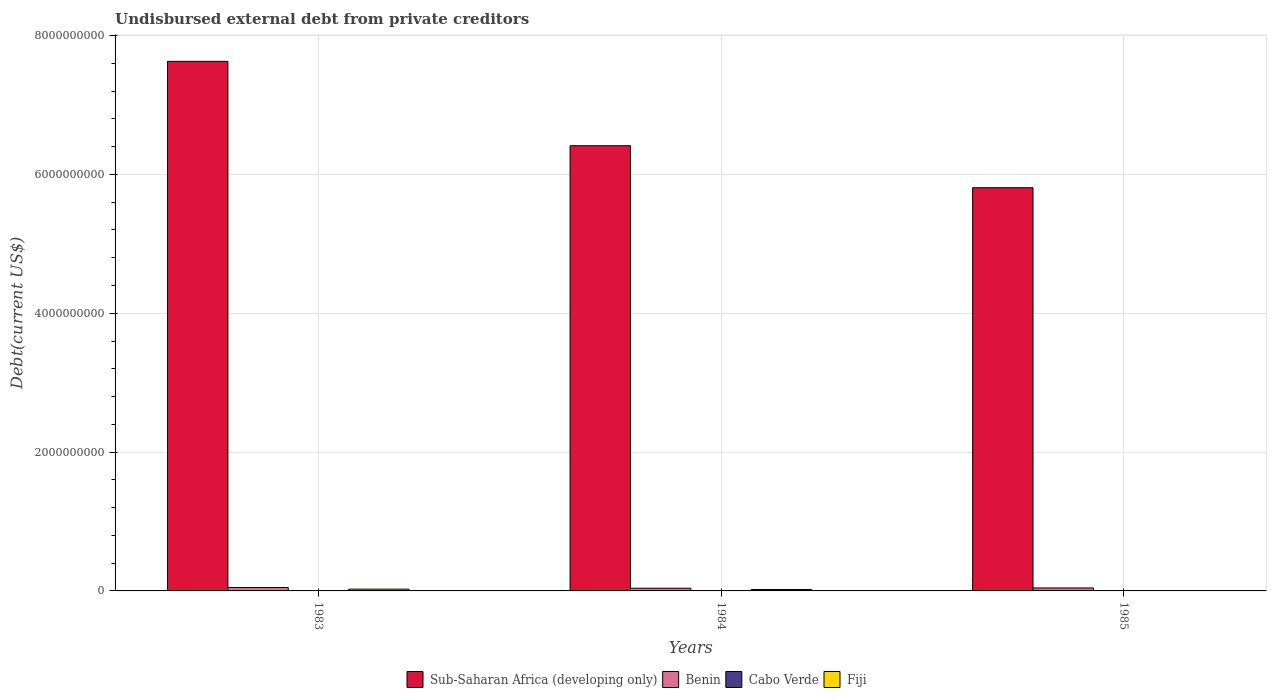How many different coloured bars are there?
Keep it short and to the point. 4. How many groups of bars are there?
Provide a short and direct response. 3. Are the number of bars per tick equal to the number of legend labels?
Offer a terse response. Yes. How many bars are there on the 1st tick from the right?
Make the answer very short. 4. What is the label of the 3rd group of bars from the left?
Provide a succinct answer. 1985. What is the total debt in Sub-Saharan Africa (developing only) in 1984?
Keep it short and to the point. 6.41e+09. Across all years, what is the maximum total debt in Benin?
Offer a very short reply. 4.94e+07. Across all years, what is the minimum total debt in Benin?
Your answer should be very brief. 3.91e+07. In which year was the total debt in Sub-Saharan Africa (developing only) minimum?
Ensure brevity in your answer.  1985. What is the total total debt in Cabo Verde in the graph?
Your response must be concise. 5.15e+06. What is the difference between the total debt in Sub-Saharan Africa (developing only) in 1983 and that in 1985?
Keep it short and to the point. 1.82e+09. What is the difference between the total debt in Benin in 1983 and the total debt in Cabo Verde in 1985?
Your answer should be compact. 4.88e+07. What is the average total debt in Fiji per year?
Offer a very short reply. 1.62e+07. In the year 1985, what is the difference between the total debt in Fiji and total debt in Benin?
Give a very brief answer. -4.09e+07. What is the ratio of the total debt in Cabo Verde in 1984 to that in 1985?
Provide a succinct answer. 2.64. Is the difference between the total debt in Fiji in 1984 and 1985 greater than the difference between the total debt in Benin in 1984 and 1985?
Your answer should be very brief. Yes. What is the difference between the highest and the second highest total debt in Fiji?
Your response must be concise. 4.91e+06. What is the difference between the highest and the lowest total debt in Sub-Saharan Africa (developing only)?
Provide a succinct answer. 1.82e+09. Is the sum of the total debt in Benin in 1983 and 1985 greater than the maximum total debt in Sub-Saharan Africa (developing only) across all years?
Provide a succinct answer. No. Is it the case that in every year, the sum of the total debt in Benin and total debt in Cabo Verde is greater than the sum of total debt in Sub-Saharan Africa (developing only) and total debt in Fiji?
Keep it short and to the point. No. What does the 3rd bar from the left in 1983 represents?
Your response must be concise. Cabo Verde. What does the 3rd bar from the right in 1984 represents?
Provide a succinct answer. Benin. What is the difference between two consecutive major ticks on the Y-axis?
Give a very brief answer. 2.00e+09. Are the values on the major ticks of Y-axis written in scientific E-notation?
Your answer should be very brief. No. Does the graph contain any zero values?
Your answer should be compact. No. Does the graph contain grids?
Provide a short and direct response. Yes. How many legend labels are there?
Ensure brevity in your answer.  4. What is the title of the graph?
Provide a succinct answer. Undisbursed external debt from private creditors. What is the label or title of the Y-axis?
Provide a succinct answer. Debt(current US$). What is the Debt(current US$) in Sub-Saharan Africa (developing only) in 1983?
Offer a terse response. 7.63e+09. What is the Debt(current US$) in Benin in 1983?
Provide a succinct answer. 4.94e+07. What is the Debt(current US$) of Cabo Verde in 1983?
Make the answer very short. 3.00e+06. What is the Debt(current US$) in Fiji in 1983?
Your response must be concise. 2.58e+07. What is the Debt(current US$) of Sub-Saharan Africa (developing only) in 1984?
Provide a short and direct response. 6.41e+09. What is the Debt(current US$) of Benin in 1984?
Your answer should be very brief. 3.91e+07. What is the Debt(current US$) in Cabo Verde in 1984?
Your answer should be compact. 1.56e+06. What is the Debt(current US$) of Fiji in 1984?
Your answer should be very brief. 2.09e+07. What is the Debt(current US$) in Sub-Saharan Africa (developing only) in 1985?
Offer a terse response. 5.81e+09. What is the Debt(current US$) of Benin in 1985?
Offer a very short reply. 4.27e+07. What is the Debt(current US$) in Cabo Verde in 1985?
Offer a terse response. 5.91e+05. What is the Debt(current US$) of Fiji in 1985?
Ensure brevity in your answer.  1.78e+06. Across all years, what is the maximum Debt(current US$) in Sub-Saharan Africa (developing only)?
Give a very brief answer. 7.63e+09. Across all years, what is the maximum Debt(current US$) in Benin?
Your answer should be very brief. 4.94e+07. Across all years, what is the maximum Debt(current US$) of Cabo Verde?
Ensure brevity in your answer.  3.00e+06. Across all years, what is the maximum Debt(current US$) in Fiji?
Your answer should be compact. 2.58e+07. Across all years, what is the minimum Debt(current US$) in Sub-Saharan Africa (developing only)?
Your answer should be very brief. 5.81e+09. Across all years, what is the minimum Debt(current US$) of Benin?
Provide a succinct answer. 3.91e+07. Across all years, what is the minimum Debt(current US$) of Cabo Verde?
Offer a very short reply. 5.91e+05. Across all years, what is the minimum Debt(current US$) in Fiji?
Offer a very short reply. 1.78e+06. What is the total Debt(current US$) in Sub-Saharan Africa (developing only) in the graph?
Your answer should be compact. 1.99e+1. What is the total Debt(current US$) in Benin in the graph?
Offer a terse response. 1.31e+08. What is the total Debt(current US$) in Cabo Verde in the graph?
Your answer should be compact. 5.15e+06. What is the total Debt(current US$) in Fiji in the graph?
Give a very brief answer. 4.85e+07. What is the difference between the Debt(current US$) in Sub-Saharan Africa (developing only) in 1983 and that in 1984?
Keep it short and to the point. 1.22e+09. What is the difference between the Debt(current US$) of Benin in 1983 and that in 1984?
Make the answer very short. 1.04e+07. What is the difference between the Debt(current US$) of Cabo Verde in 1983 and that in 1984?
Provide a short and direct response. 1.44e+06. What is the difference between the Debt(current US$) in Fiji in 1983 and that in 1984?
Ensure brevity in your answer.  4.91e+06. What is the difference between the Debt(current US$) of Sub-Saharan Africa (developing only) in 1983 and that in 1985?
Offer a very short reply. 1.82e+09. What is the difference between the Debt(current US$) in Benin in 1983 and that in 1985?
Keep it short and to the point. 6.72e+06. What is the difference between the Debt(current US$) of Cabo Verde in 1983 and that in 1985?
Give a very brief answer. 2.41e+06. What is the difference between the Debt(current US$) in Fiji in 1983 and that in 1985?
Give a very brief answer. 2.40e+07. What is the difference between the Debt(current US$) of Sub-Saharan Africa (developing only) in 1984 and that in 1985?
Your answer should be very brief. 6.05e+08. What is the difference between the Debt(current US$) of Benin in 1984 and that in 1985?
Ensure brevity in your answer.  -3.65e+06. What is the difference between the Debt(current US$) of Cabo Verde in 1984 and that in 1985?
Offer a terse response. 9.72e+05. What is the difference between the Debt(current US$) of Fiji in 1984 and that in 1985?
Your answer should be compact. 1.91e+07. What is the difference between the Debt(current US$) in Sub-Saharan Africa (developing only) in 1983 and the Debt(current US$) in Benin in 1984?
Your answer should be very brief. 7.59e+09. What is the difference between the Debt(current US$) in Sub-Saharan Africa (developing only) in 1983 and the Debt(current US$) in Cabo Verde in 1984?
Your answer should be very brief. 7.63e+09. What is the difference between the Debt(current US$) of Sub-Saharan Africa (developing only) in 1983 and the Debt(current US$) of Fiji in 1984?
Provide a short and direct response. 7.61e+09. What is the difference between the Debt(current US$) of Benin in 1983 and the Debt(current US$) of Cabo Verde in 1984?
Your response must be concise. 4.79e+07. What is the difference between the Debt(current US$) in Benin in 1983 and the Debt(current US$) in Fiji in 1984?
Ensure brevity in your answer.  2.85e+07. What is the difference between the Debt(current US$) in Cabo Verde in 1983 and the Debt(current US$) in Fiji in 1984?
Your response must be concise. -1.79e+07. What is the difference between the Debt(current US$) in Sub-Saharan Africa (developing only) in 1983 and the Debt(current US$) in Benin in 1985?
Offer a very short reply. 7.59e+09. What is the difference between the Debt(current US$) of Sub-Saharan Africa (developing only) in 1983 and the Debt(current US$) of Cabo Verde in 1985?
Keep it short and to the point. 7.63e+09. What is the difference between the Debt(current US$) in Sub-Saharan Africa (developing only) in 1983 and the Debt(current US$) in Fiji in 1985?
Your answer should be compact. 7.63e+09. What is the difference between the Debt(current US$) of Benin in 1983 and the Debt(current US$) of Cabo Verde in 1985?
Provide a succinct answer. 4.88e+07. What is the difference between the Debt(current US$) in Benin in 1983 and the Debt(current US$) in Fiji in 1985?
Your answer should be compact. 4.76e+07. What is the difference between the Debt(current US$) of Cabo Verde in 1983 and the Debt(current US$) of Fiji in 1985?
Keep it short and to the point. 1.22e+06. What is the difference between the Debt(current US$) in Sub-Saharan Africa (developing only) in 1984 and the Debt(current US$) in Benin in 1985?
Your response must be concise. 6.37e+09. What is the difference between the Debt(current US$) in Sub-Saharan Africa (developing only) in 1984 and the Debt(current US$) in Cabo Verde in 1985?
Provide a short and direct response. 6.41e+09. What is the difference between the Debt(current US$) in Sub-Saharan Africa (developing only) in 1984 and the Debt(current US$) in Fiji in 1985?
Your response must be concise. 6.41e+09. What is the difference between the Debt(current US$) in Benin in 1984 and the Debt(current US$) in Cabo Verde in 1985?
Offer a very short reply. 3.85e+07. What is the difference between the Debt(current US$) of Benin in 1984 and the Debt(current US$) of Fiji in 1985?
Provide a short and direct response. 3.73e+07. What is the difference between the Debt(current US$) in Cabo Verde in 1984 and the Debt(current US$) in Fiji in 1985?
Your response must be concise. -2.22e+05. What is the average Debt(current US$) in Sub-Saharan Africa (developing only) per year?
Provide a succinct answer. 6.62e+09. What is the average Debt(current US$) in Benin per year?
Make the answer very short. 4.37e+07. What is the average Debt(current US$) of Cabo Verde per year?
Offer a terse response. 1.72e+06. What is the average Debt(current US$) in Fiji per year?
Provide a succinct answer. 1.62e+07. In the year 1983, what is the difference between the Debt(current US$) of Sub-Saharan Africa (developing only) and Debt(current US$) of Benin?
Offer a terse response. 7.58e+09. In the year 1983, what is the difference between the Debt(current US$) in Sub-Saharan Africa (developing only) and Debt(current US$) in Cabo Verde?
Provide a short and direct response. 7.63e+09. In the year 1983, what is the difference between the Debt(current US$) of Sub-Saharan Africa (developing only) and Debt(current US$) of Fiji?
Make the answer very short. 7.60e+09. In the year 1983, what is the difference between the Debt(current US$) in Benin and Debt(current US$) in Cabo Verde?
Make the answer very short. 4.64e+07. In the year 1983, what is the difference between the Debt(current US$) of Benin and Debt(current US$) of Fiji?
Provide a succinct answer. 2.36e+07. In the year 1983, what is the difference between the Debt(current US$) in Cabo Verde and Debt(current US$) in Fiji?
Your response must be concise. -2.28e+07. In the year 1984, what is the difference between the Debt(current US$) in Sub-Saharan Africa (developing only) and Debt(current US$) in Benin?
Offer a terse response. 6.37e+09. In the year 1984, what is the difference between the Debt(current US$) of Sub-Saharan Africa (developing only) and Debt(current US$) of Cabo Verde?
Offer a terse response. 6.41e+09. In the year 1984, what is the difference between the Debt(current US$) of Sub-Saharan Africa (developing only) and Debt(current US$) of Fiji?
Give a very brief answer. 6.39e+09. In the year 1984, what is the difference between the Debt(current US$) in Benin and Debt(current US$) in Cabo Verde?
Your answer should be very brief. 3.75e+07. In the year 1984, what is the difference between the Debt(current US$) of Benin and Debt(current US$) of Fiji?
Provide a succinct answer. 1.81e+07. In the year 1984, what is the difference between the Debt(current US$) in Cabo Verde and Debt(current US$) in Fiji?
Your answer should be compact. -1.94e+07. In the year 1985, what is the difference between the Debt(current US$) in Sub-Saharan Africa (developing only) and Debt(current US$) in Benin?
Keep it short and to the point. 5.77e+09. In the year 1985, what is the difference between the Debt(current US$) in Sub-Saharan Africa (developing only) and Debt(current US$) in Cabo Verde?
Offer a terse response. 5.81e+09. In the year 1985, what is the difference between the Debt(current US$) in Sub-Saharan Africa (developing only) and Debt(current US$) in Fiji?
Your answer should be very brief. 5.81e+09. In the year 1985, what is the difference between the Debt(current US$) in Benin and Debt(current US$) in Cabo Verde?
Your answer should be very brief. 4.21e+07. In the year 1985, what is the difference between the Debt(current US$) of Benin and Debt(current US$) of Fiji?
Offer a very short reply. 4.09e+07. In the year 1985, what is the difference between the Debt(current US$) in Cabo Verde and Debt(current US$) in Fiji?
Make the answer very short. -1.19e+06. What is the ratio of the Debt(current US$) of Sub-Saharan Africa (developing only) in 1983 to that in 1984?
Offer a very short reply. 1.19. What is the ratio of the Debt(current US$) in Benin in 1983 to that in 1984?
Your answer should be compact. 1.27. What is the ratio of the Debt(current US$) of Cabo Verde in 1983 to that in 1984?
Provide a succinct answer. 1.92. What is the ratio of the Debt(current US$) of Fiji in 1983 to that in 1984?
Offer a very short reply. 1.23. What is the ratio of the Debt(current US$) in Sub-Saharan Africa (developing only) in 1983 to that in 1985?
Provide a short and direct response. 1.31. What is the ratio of the Debt(current US$) in Benin in 1983 to that in 1985?
Your answer should be compact. 1.16. What is the ratio of the Debt(current US$) of Cabo Verde in 1983 to that in 1985?
Your answer should be compact. 5.08. What is the ratio of the Debt(current US$) of Fiji in 1983 to that in 1985?
Offer a very short reply. 14.47. What is the ratio of the Debt(current US$) in Sub-Saharan Africa (developing only) in 1984 to that in 1985?
Provide a succinct answer. 1.1. What is the ratio of the Debt(current US$) in Benin in 1984 to that in 1985?
Offer a terse response. 0.91. What is the ratio of the Debt(current US$) in Cabo Verde in 1984 to that in 1985?
Keep it short and to the point. 2.64. What is the ratio of the Debt(current US$) in Fiji in 1984 to that in 1985?
Ensure brevity in your answer.  11.72. What is the difference between the highest and the second highest Debt(current US$) of Sub-Saharan Africa (developing only)?
Your response must be concise. 1.22e+09. What is the difference between the highest and the second highest Debt(current US$) in Benin?
Your answer should be compact. 6.72e+06. What is the difference between the highest and the second highest Debt(current US$) in Cabo Verde?
Provide a short and direct response. 1.44e+06. What is the difference between the highest and the second highest Debt(current US$) in Fiji?
Ensure brevity in your answer.  4.91e+06. What is the difference between the highest and the lowest Debt(current US$) in Sub-Saharan Africa (developing only)?
Provide a succinct answer. 1.82e+09. What is the difference between the highest and the lowest Debt(current US$) in Benin?
Your answer should be compact. 1.04e+07. What is the difference between the highest and the lowest Debt(current US$) of Cabo Verde?
Your answer should be very brief. 2.41e+06. What is the difference between the highest and the lowest Debt(current US$) of Fiji?
Offer a terse response. 2.40e+07. 